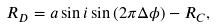<formula> <loc_0><loc_0><loc_500><loc_500>R _ { D } = a \sin { i } \sin { ( 2 \pi \Delta \phi ) } - R _ { C } ,</formula> 